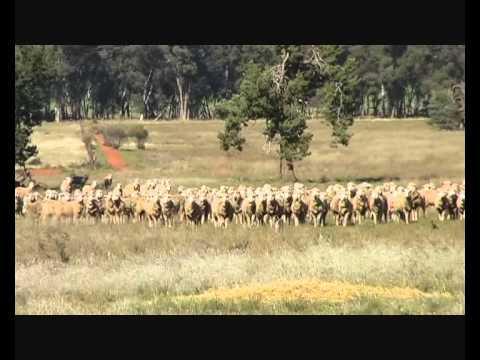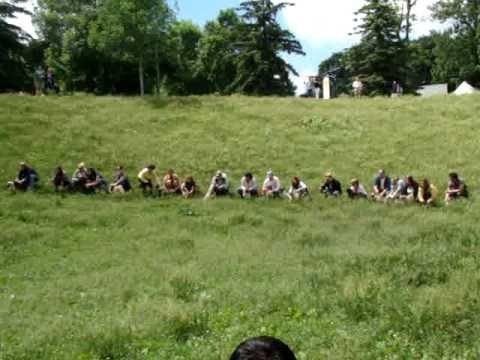The first image is the image on the left, the second image is the image on the right. For the images shown, is this caption "In one image, a woman is shown with many little dogs." true? Answer yes or no. No. 